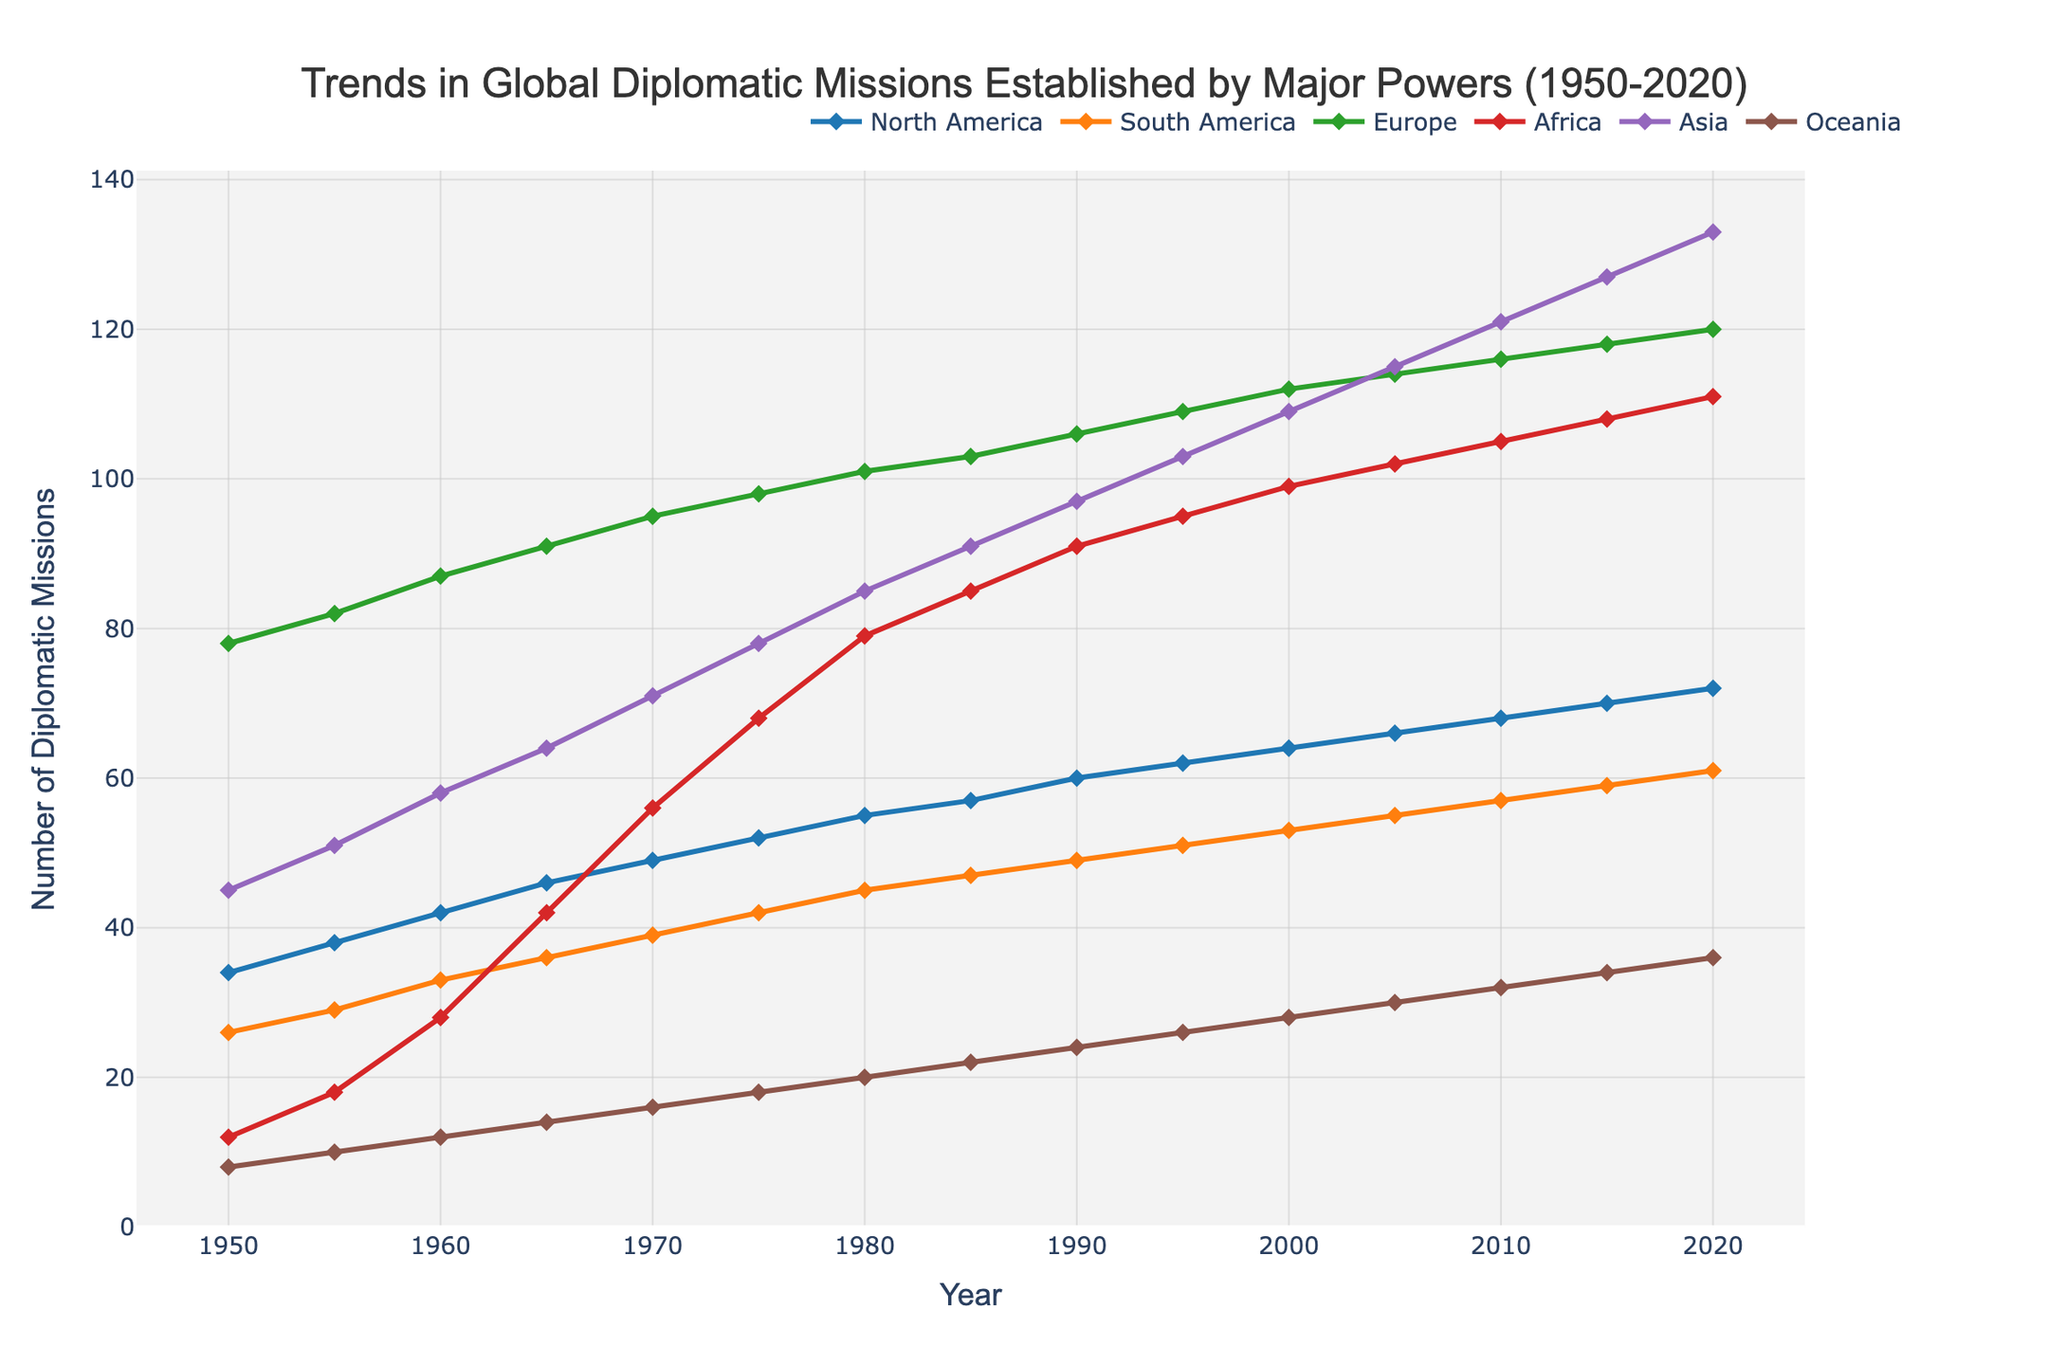What is the general trend in the number of European diplomatic missions from 1950 to 2020? By examining the line representing Europe, we see a steady increase from 78 in 1950 to 120 in 2020. This suggests a continuous and positive trend over the 70 years.
Answer: Continuous increase Which continent had the most significant increase in diplomatic missions from 1950 to 2020? By comparing the line slopes of all six continents, Asia shows the most significant increase, from 45 in 1950 to 133 in 2020. The increase is 133 - 45 = 88, which is higher than any other continent's increase.
Answer: Asia Between which two consecutive decades did Africa have the largest increase in diplomatic missions? Examining the slope of Africa's line across each decade, the largest increase occurred between 1965 and 1975, where the number of missions rose from 42 to 68, an increase of 26 missions.
Answer: 1965-1975 Which continent had the least number of diplomatic missions in 1950, and how many were there? By looking at the starting points of the lines in 1950, Oceania had the least number of diplomatic missions with 8 missions.
Answer: Oceania, 8 Has Oceania ever surpassed South America in the number of diplomatic missions during the given years? By comparing the lines for Oceania and South America, Oceania has always remained below South America in the number of diplomatic missions throughout the years 1950 to 2020.
Answer: No What is the average number of diplomatic missions in South America across all the years provided? Sum the values for South America across all provided years and then divide by the number of years: (26+29+33+36+39+42+45+47+49+51+53+55+57+59+61)/15 = 673/15 = 44.87.
Answer: 44.87 How does the number of diplomatic missions in Asia in 2020 compare to the same year's data in Europe? In 2020, Asia had 133 diplomatic missions while Europe had 120. Asia had 133 - 120 = 13 more missions than Europe.
Answer: 13 more Which continent shows the most consistent growth over the decades, and how can you tell? By observing the smoothness and steadiness of the line, North America shows the most consistent growth with no sharp increases or decreases, maintaining a relatively stable increase from 34 in 1950 to 72 in 2020.
Answer: North America What’s the total number of diplomatic missions established across all continents in 1980? Add the values for each continent in 1980: 55 (North America) + 45 (South America) + 101 (Europe) + 79 (Africa) + 85 (Asia) + 20 (Oceania) = 385.
Answer: 385 Which continents had at least 100 diplomatic missions by the year 2000? By examining the values in the year 2000, Europe (112), Asia (109), and Africa (99) (which is just below 100). Therefore, the continents with at least 100 diplomatic missions are Europe and Asia.
Answer: Europe, Asia 